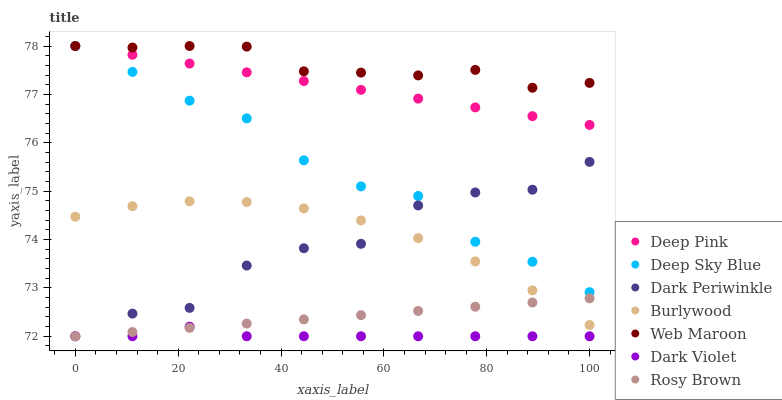Does Dark Violet have the minimum area under the curve?
Answer yes or no. Yes. Does Web Maroon have the maximum area under the curve?
Answer yes or no. Yes. Does Burlywood have the minimum area under the curve?
Answer yes or no. No. Does Burlywood have the maximum area under the curve?
Answer yes or no. No. Is Rosy Brown the smoothest?
Answer yes or no. Yes. Is Dark Periwinkle the roughest?
Answer yes or no. Yes. Is Burlywood the smoothest?
Answer yes or no. No. Is Burlywood the roughest?
Answer yes or no. No. Does Rosy Brown have the lowest value?
Answer yes or no. Yes. Does Burlywood have the lowest value?
Answer yes or no. No. Does Deep Sky Blue have the highest value?
Answer yes or no. Yes. Does Burlywood have the highest value?
Answer yes or no. No. Is Dark Violet less than Deep Pink?
Answer yes or no. Yes. Is Web Maroon greater than Burlywood?
Answer yes or no. Yes. Does Rosy Brown intersect Dark Periwinkle?
Answer yes or no. Yes. Is Rosy Brown less than Dark Periwinkle?
Answer yes or no. No. Is Rosy Brown greater than Dark Periwinkle?
Answer yes or no. No. Does Dark Violet intersect Deep Pink?
Answer yes or no. No. 